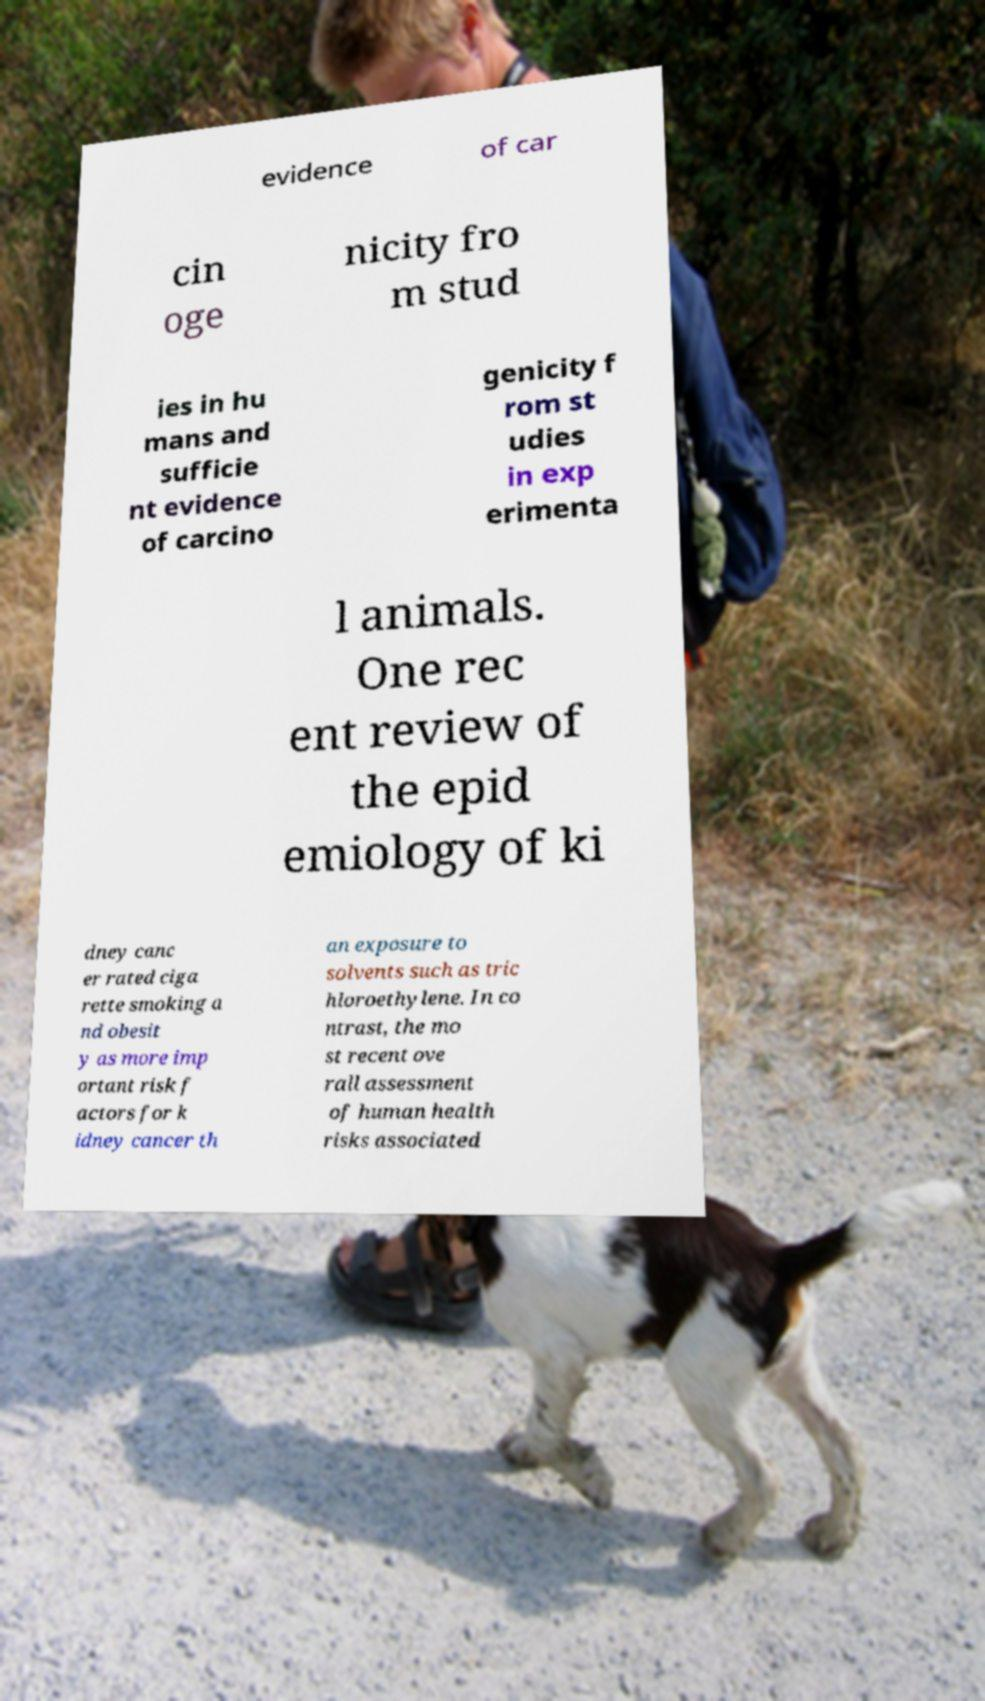What messages or text are displayed in this image? I need them in a readable, typed format. evidence of car cin oge nicity fro m stud ies in hu mans and sufficie nt evidence of carcino genicity f rom st udies in exp erimenta l animals. One rec ent review of the epid emiology of ki dney canc er rated ciga rette smoking a nd obesit y as more imp ortant risk f actors for k idney cancer th an exposure to solvents such as tric hloroethylene. In co ntrast, the mo st recent ove rall assessment of human health risks associated 